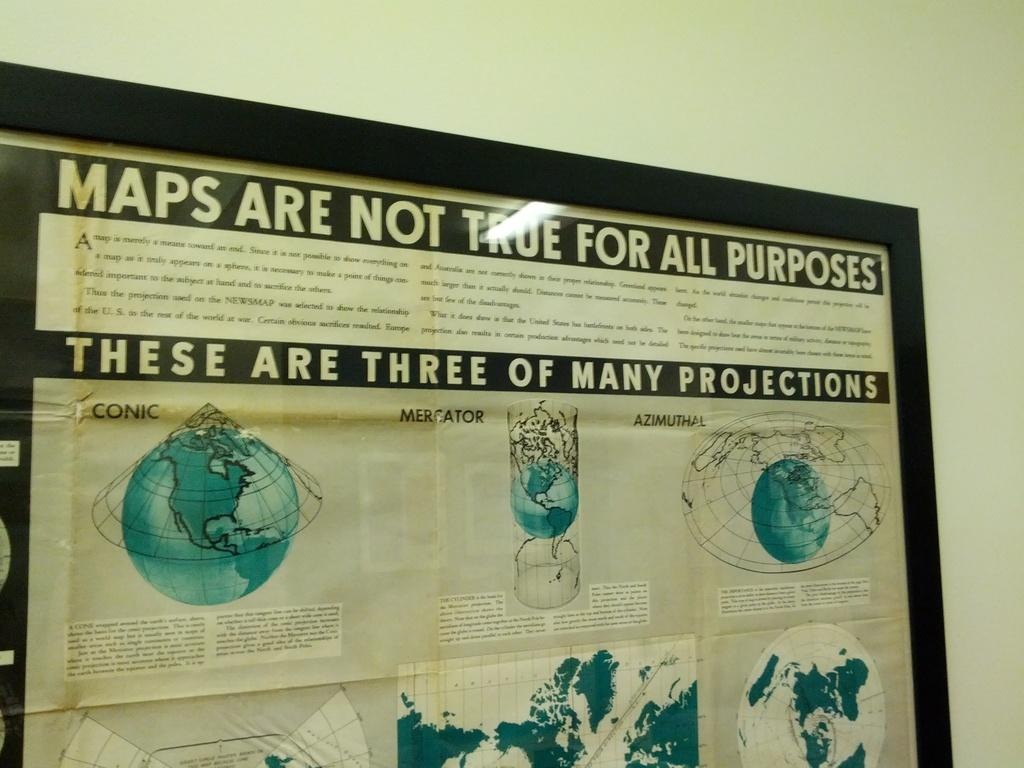<image>
Present a compact description of the photo's key features. Maps are not true for all purpose there are three projections in a frame 